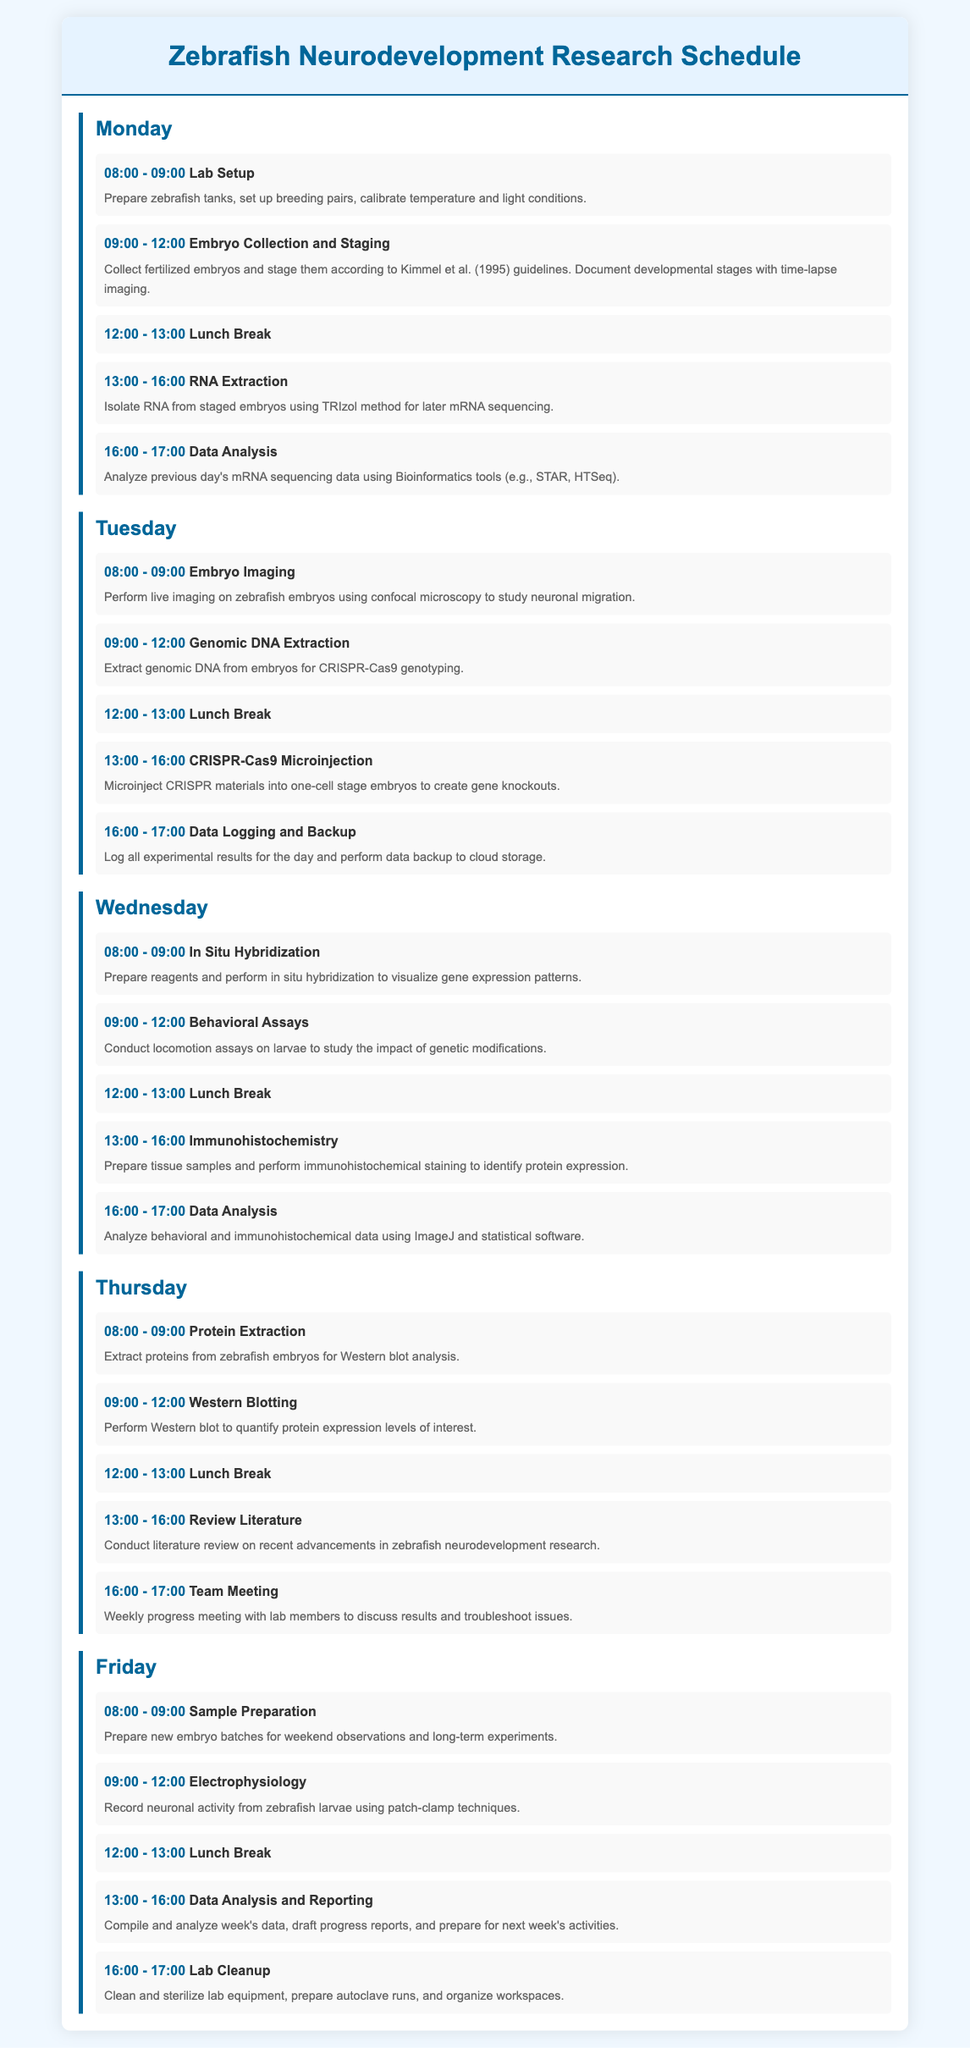what time does lab setup start on Monday? The document lists the time for lab setup on Monday which is from 08:00 to 09:00.
Answer: 08:00 how long is the lunch break scheduled each day? The document states that the lunch break is scheduled for one hour from 12:00 to 13:00 each day.
Answer: One hour what is the main focus of the Tuesday morning session? The Tuesday morning session includes the genomic DNA extraction, which is focused on extracting genomic DNA from embryos for CRISPR-Cas9 genotyping.
Answer: Genomic DNA extraction which activity involves analyzing previous day's data? The activity listed for data analysis is for analyzing previous day's mRNA sequencing data using Bioinformatics tools.
Answer: Data Analysis on which day is the team meeting scheduled? The team meeting is scheduled on Thursday at 16:00.
Answer: Thursday how many different research activities are planned for Wednesday? The document outlines five different research activities planned for Wednesday, including in situ hybridization and behavioral assays.
Answer: Five what is performed during the 13:00 to 16:00 time slot on Thursday? The time slot from 13:00 to 16:00 on Thursday is dedicated to reviewing literature on recent advancements in zebrafish neurodevelopment research.
Answer: Review Literature what technique is used for recording neuronal activity on Friday? The technique listed for recording neuronal activity is the patch-clamp technique used during the electrophysiology session.
Answer: Patch-clamp which activity concludes the weekly schedule? The last activity of the week listed is lab cleanup which occurs on Friday from 16:00 to 17:00.
Answer: Lab Cleanup 